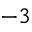Convert formula to latex. <formula><loc_0><loc_0><loc_500><loc_500>^ { - 3 }</formula> 